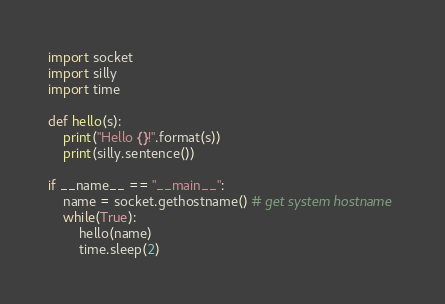<code> <loc_0><loc_0><loc_500><loc_500><_Python_>import socket
import silly
import time

def hello(s):
    print("Hello {}!".format(s))
    print(silly.sentence())

if __name__ == "__main__":
    name = socket.gethostname() # get system hostname
    while(True):
        hello(name)
        time.sleep(2)
</code> 